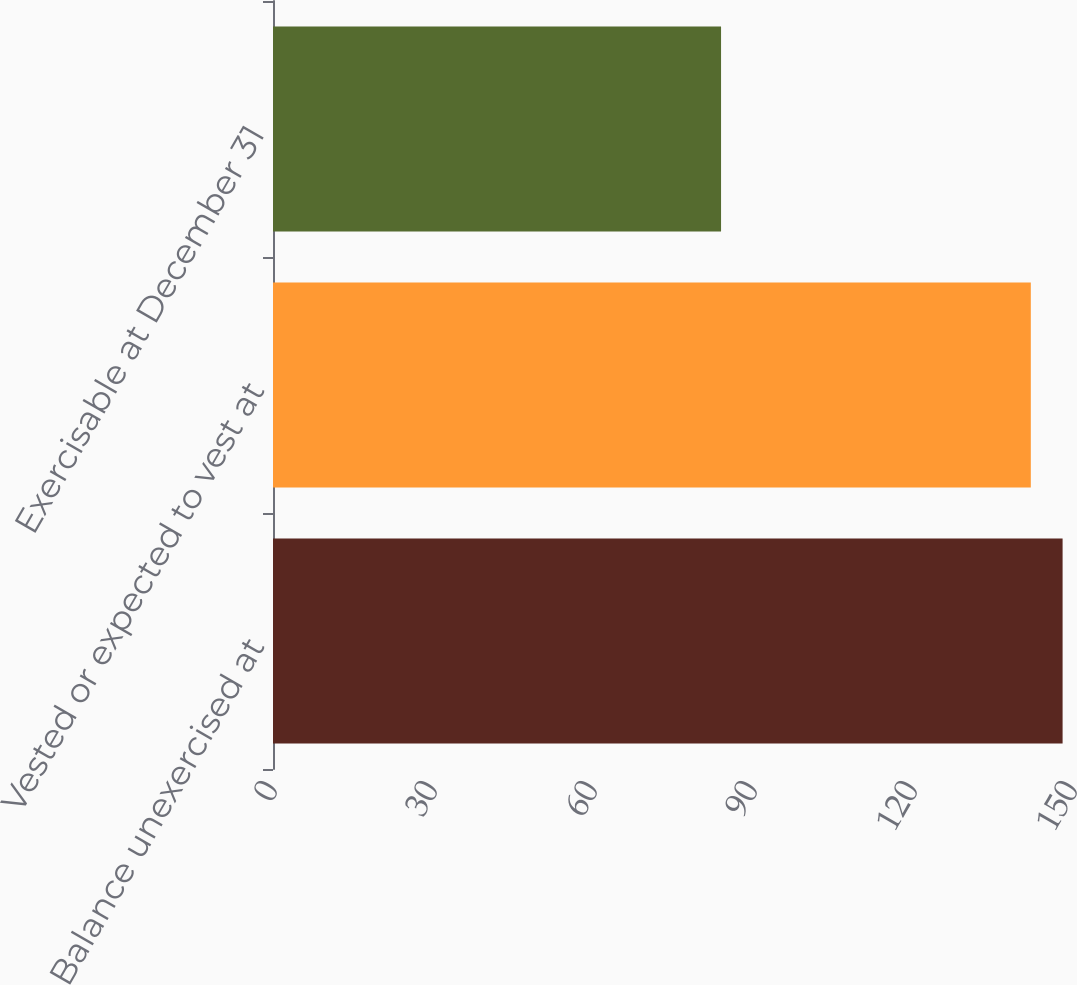<chart> <loc_0><loc_0><loc_500><loc_500><bar_chart><fcel>Balance unexercised at<fcel>Vested or expected to vest at<fcel>Exercisable at December 31<nl><fcel>148.05<fcel>142.09<fcel>84.01<nl></chart> 